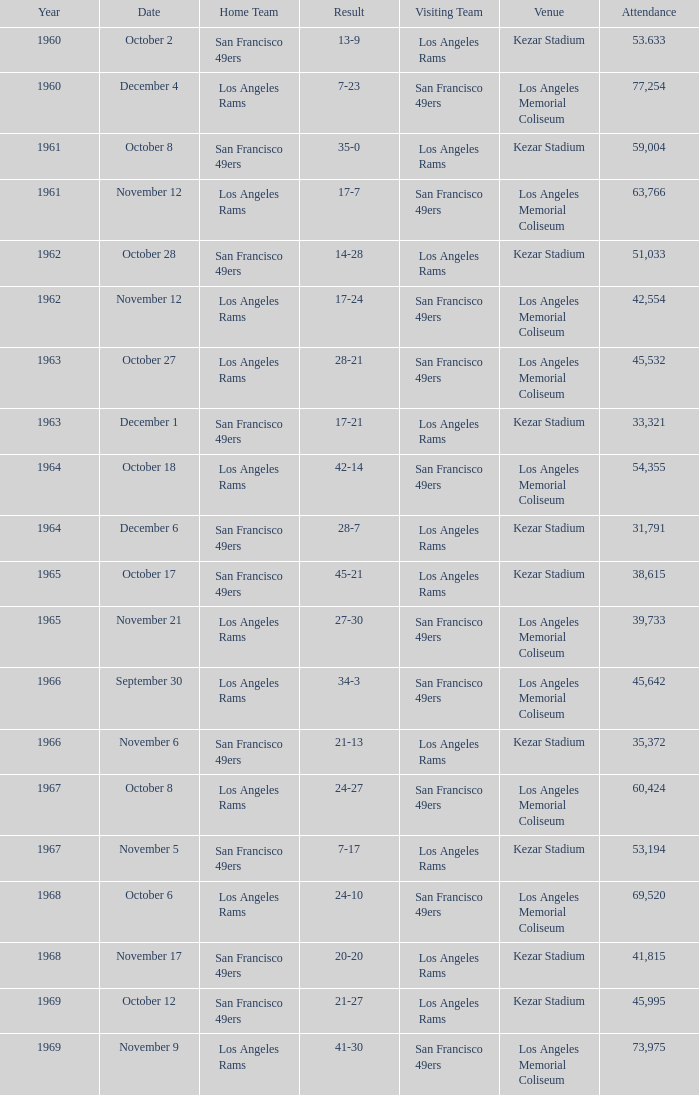What was the total attendance for a result of 7-23 before 1960? None. 